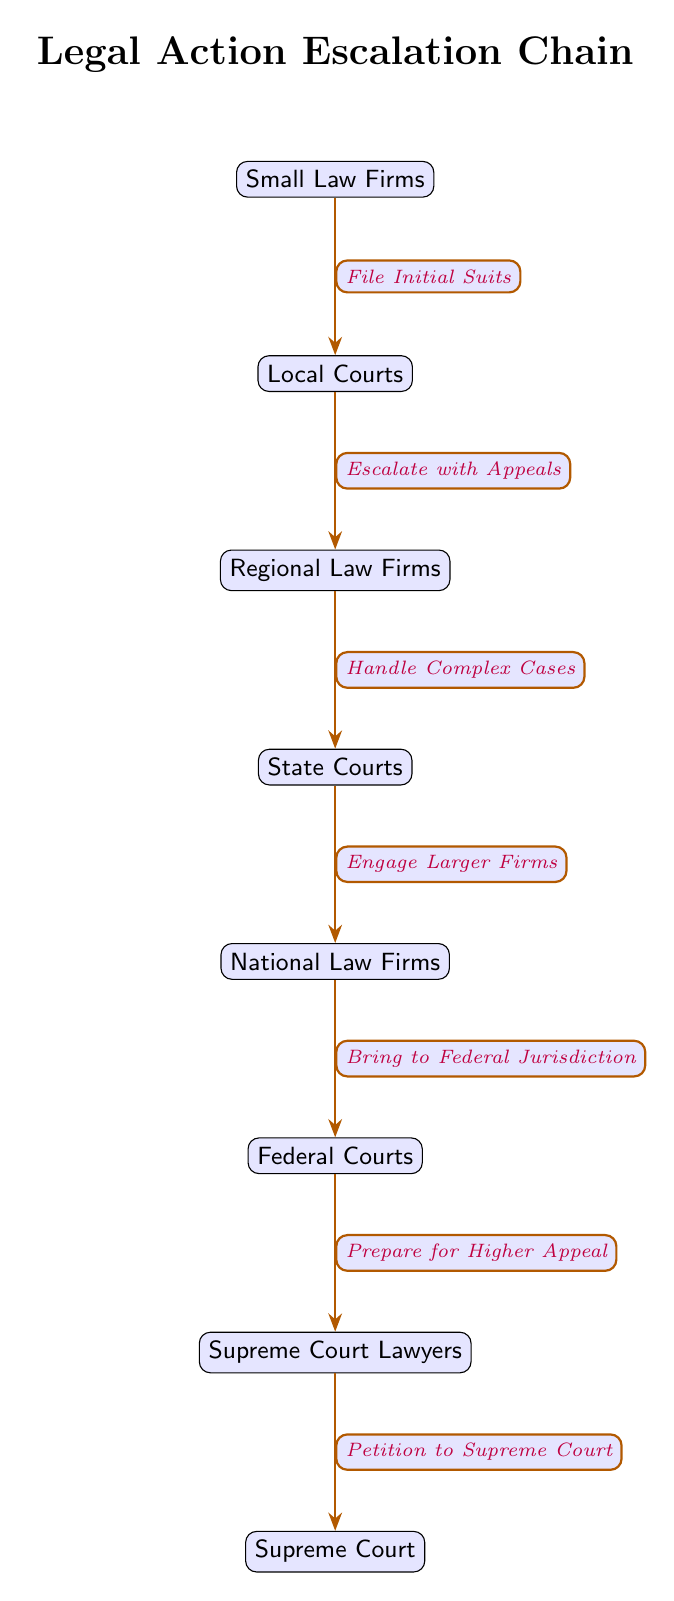What is the first step in the escalation chain? The first step involves "File Initial Suits," which is the action taken by Small Law Firms directed to the Local Courts.
Answer: File Initial Suits How many nodes are present in this diagram? The diagram consists of a total of 8 nodes that represent various stages in the legal action escalation process.
Answer: 8 What does the Local Courts do in this escalation process? The Local Courts are involved in the escalation process by allowing actions to "Escalate with Appeals" to Regional Law Firms.
Answer: Escalate with Appeals Which type of firms are involved before reaching Federal Courts? Prior to reaching the Federal Courts, the process flow includes engagement with National Law Firms, which directly lead cases there.
Answer: National Law Firms What action is taken by Federal Courts? The Federal Courts perform the action of "Prepare for Higher Appeal," which is a critical step before moving forward to the Supreme Court Lawyers.
Answer: Prepare for Higher Appeal What is the sequential relationship between State Courts and National Law Firms? The relationship shows that after cases progress from State Courts, they engage larger firms, specifically National Law Firms, which is the next step in the escalation.
Answer: Engage Larger Firms What is the final legal authority in this escalation chain? The final authority in the escalation chain is the Supreme Court, where all previous steps lead to the ultimate legal decision-making body.
Answer: Supreme Court What type of actions do Supreme Court Lawyers engage in? The Supreme Court Lawyers undertake the action of "Petition to Supreme Court," which is necessary to bring cases before this highest court.
Answer: Petition to Supreme Court 